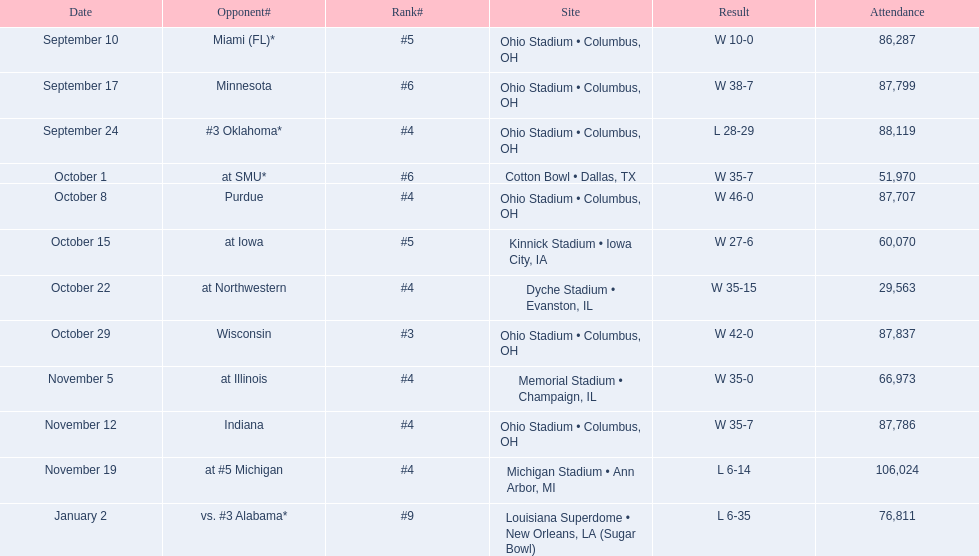What was the last game to be attended by fewer than 30,000 people? October 22. 